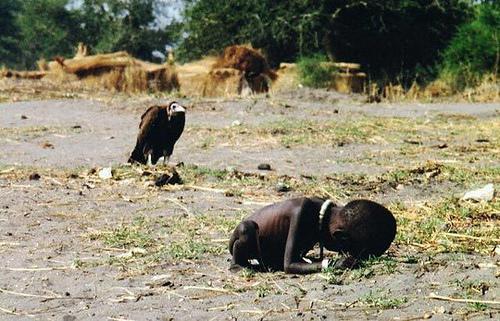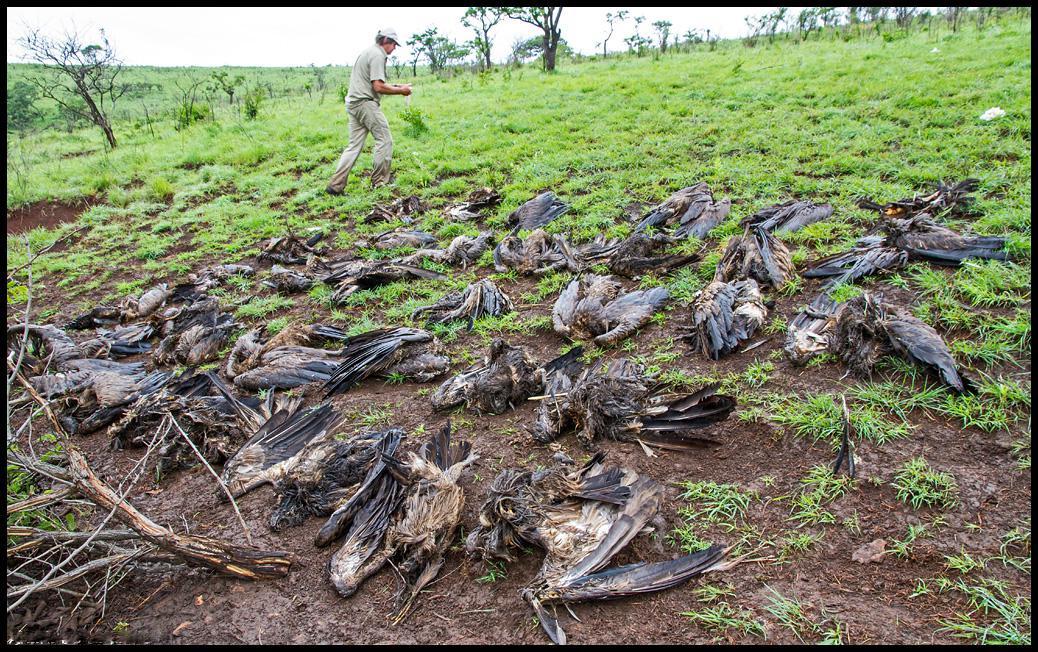The first image is the image on the left, the second image is the image on the right. Considering the images on both sides, is "there are humans in the pics" valid? Answer yes or no. Yes. The first image is the image on the left, the second image is the image on the right. For the images displayed, is the sentence "rows of dead vultures are in the grass with at least one human in the backgroud" factually correct? Answer yes or no. Yes. 